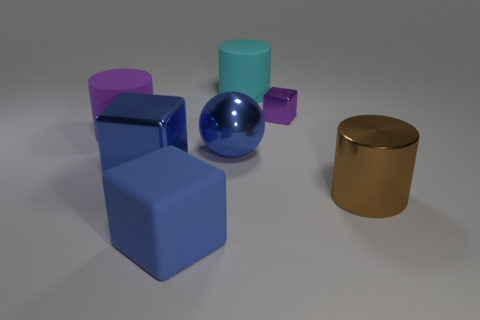Add 2 large cyan objects. How many objects exist? 9 Subtract all blue matte cubes. How many cubes are left? 2 Subtract all purple cubes. How many cubes are left? 2 Subtract 1 blocks. How many blocks are left? 2 Subtract all cyan cylinders. How many yellow balls are left? 0 Subtract all purple rubber cylinders. Subtract all large rubber things. How many objects are left? 3 Add 4 brown shiny cylinders. How many brown shiny cylinders are left? 5 Add 3 brown cylinders. How many brown cylinders exist? 4 Subtract 1 blue cubes. How many objects are left? 6 Subtract all balls. How many objects are left? 6 